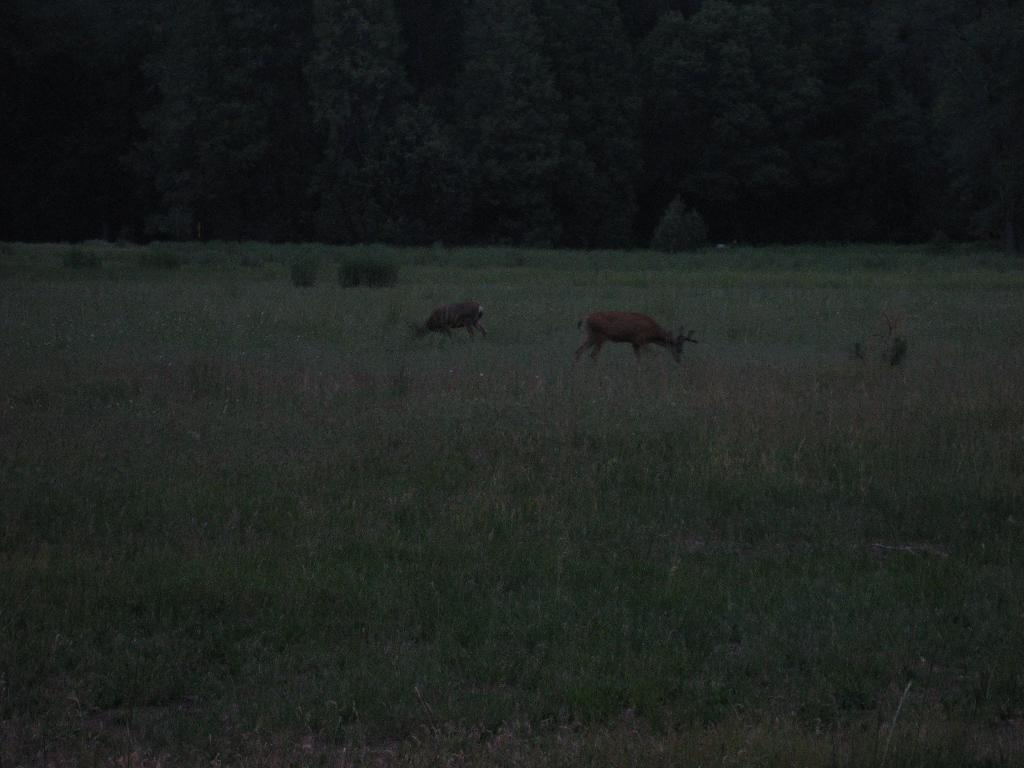What animals can be seen in the image? There are deers in the image. What are the deers doing in the image? The deers are grazing in a field. What can be seen in the background of the image? There are trees in the background of the image. What type of condition does the snail have in the image? There is no snail present in the image, so it is not possible to determine any condition it might have. What type of game are the deers playing in the image? The deers are not playing any game in the image; they are grazing in a field. 